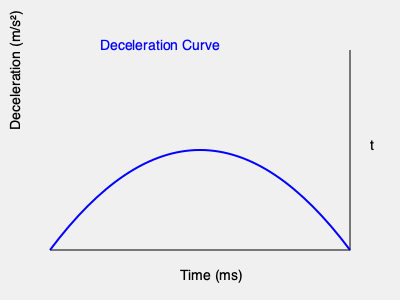As a boxing coach, you're analyzing the impact force of a glove during a punch. Given the deceleration curve shown in the graph, where the area under the curve represents the change in velocity, and assuming the mass of the glove is 0.4 kg, estimate the average impact force exerted by the glove. The time interval for the impact is 50 ms. To solve this problem, we'll follow these steps:

1) The area under the deceleration-time curve represents the change in velocity. Let's estimate this area:
   - The curve resembles a quarter circle, so we can approximate the area as: 
     $$A = \frac{1}{4} \pi r^2$$
   - The "radius" is about 200 m/s² (peak deceleration) and 25 ms (half the time interval)
   - $$A = \frac{1}{4} \pi (200 \cdot 0.025)^2 = 0.0982 \text{ m/s}$$

2) This area (0.0982 m/s) represents the change in velocity (Δv)

3) We can use the impulse-momentum theorem: $$F \cdot \Delta t = m \cdot \Delta v$$

4) Rearranging for force: $$F = \frac{m \cdot \Delta v}{\Delta t}$$

5) Plugging in our values:
   $$F = \frac{0.4 \text{ kg} \cdot 0.0982 \text{ m/s}}{0.05 \text{ s}} = 0.7856 \text{ N}$$

6) This is the average force over the impact interval.
Answer: 0.79 N 